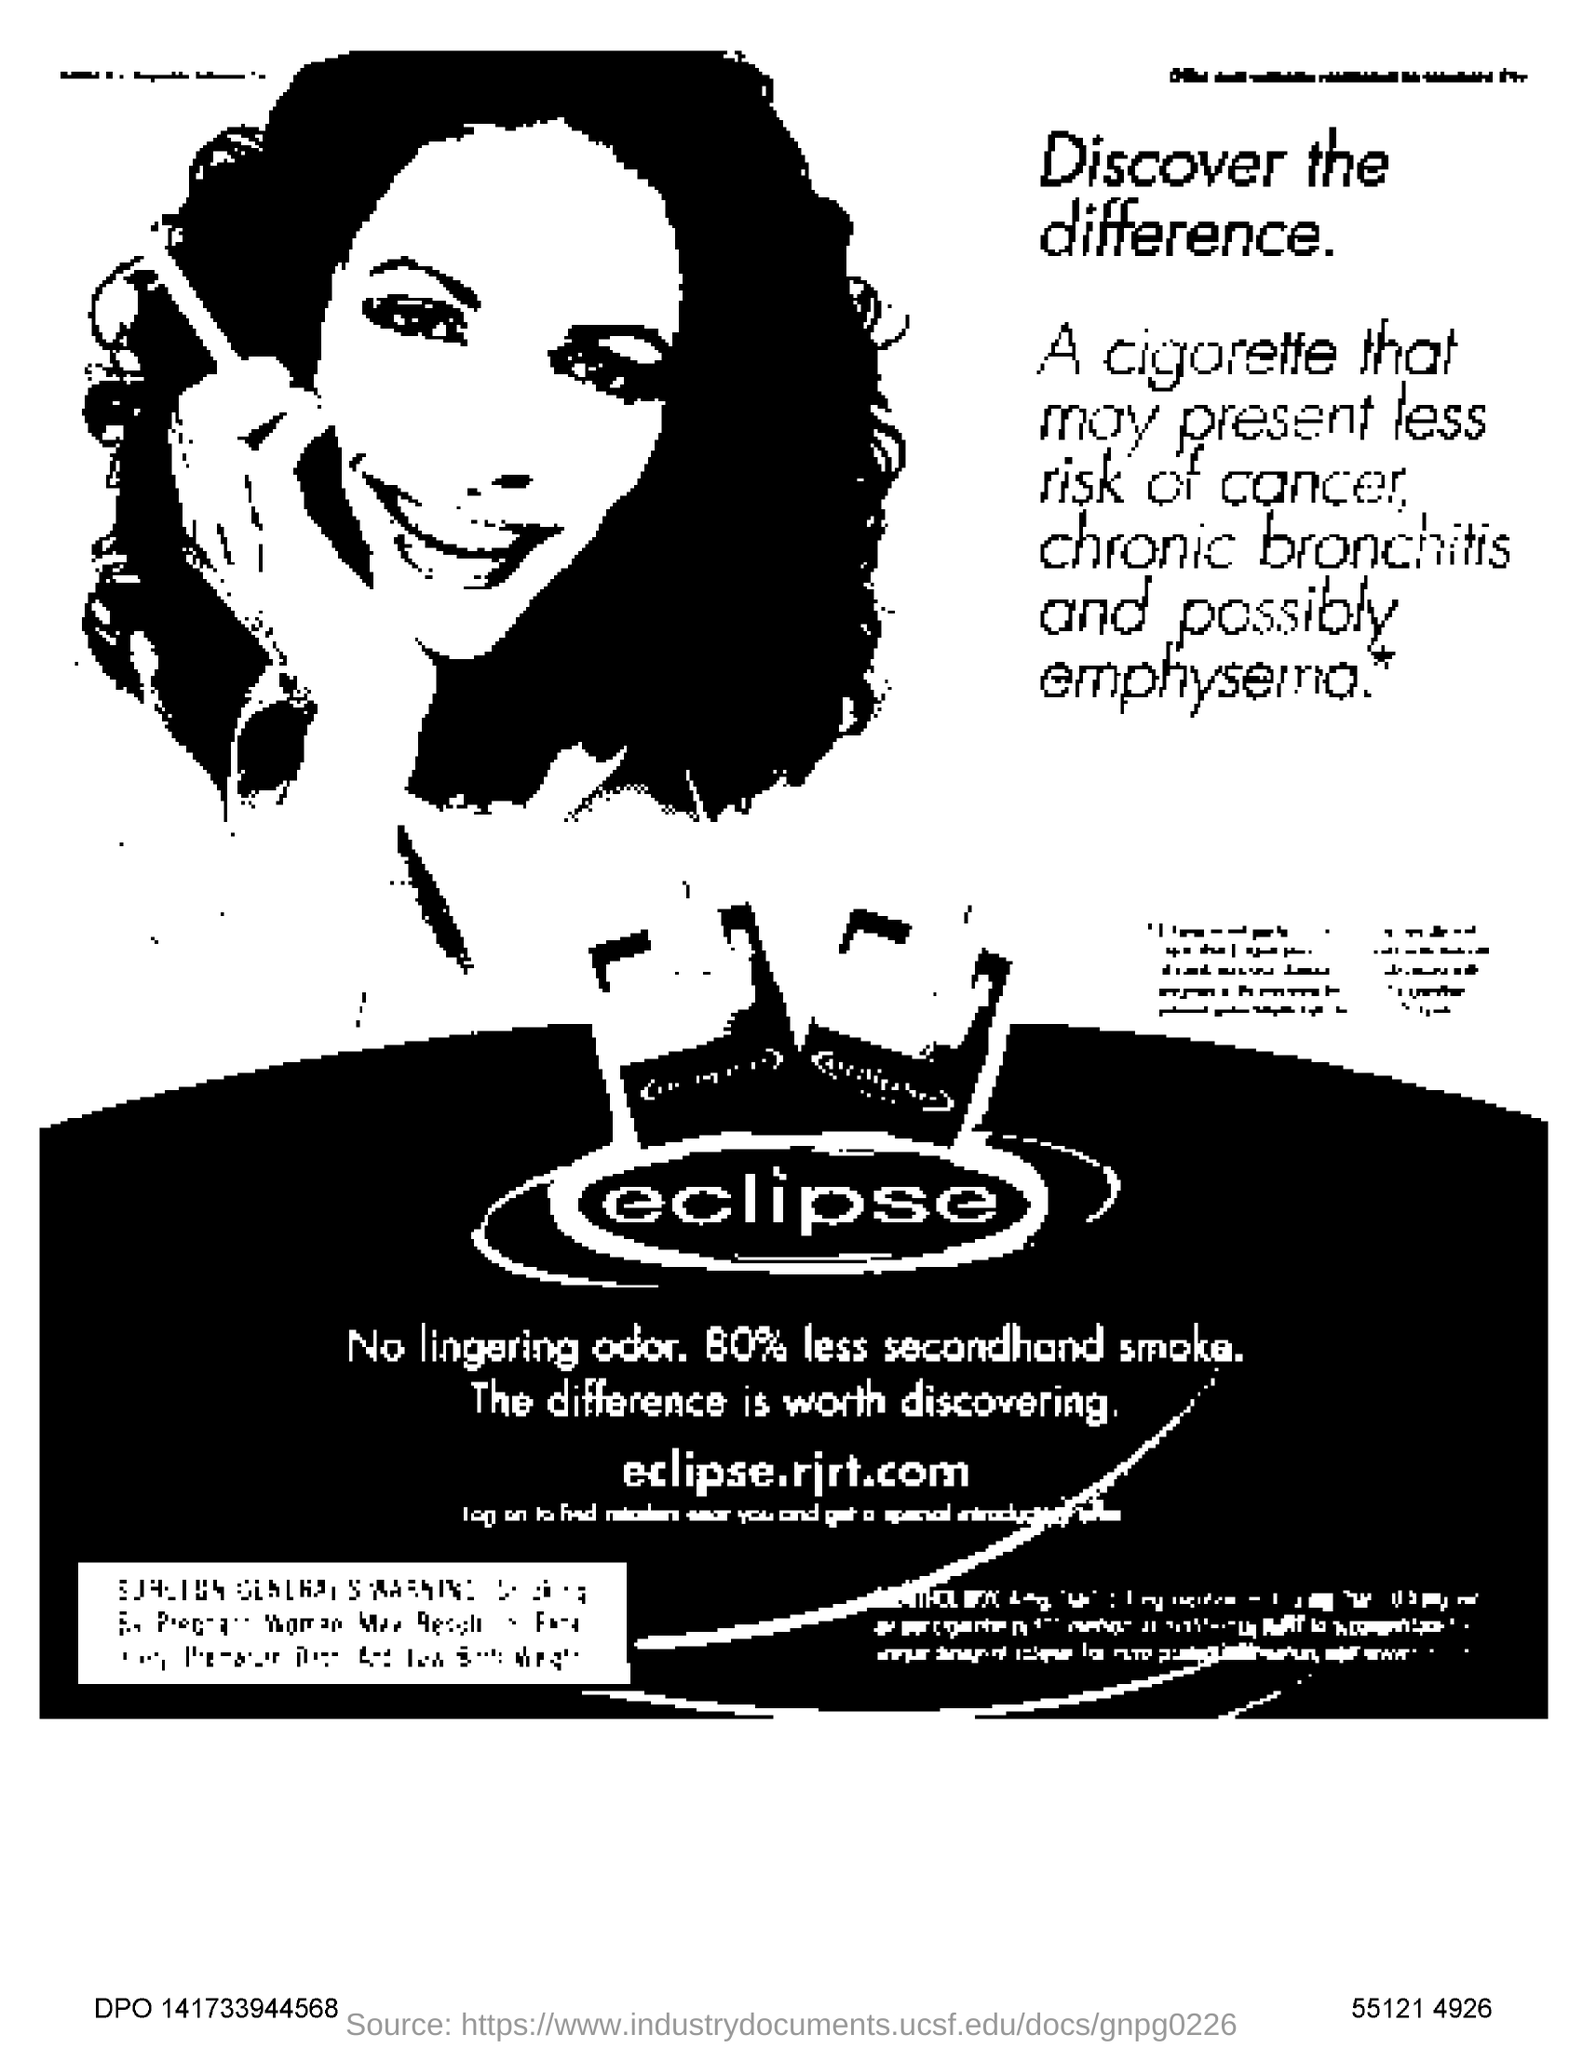Draw attention to some important aspects in this diagram. The advertisement is for Eclipse Company. The advertisement lists a website as "eclipserjrt.com. 